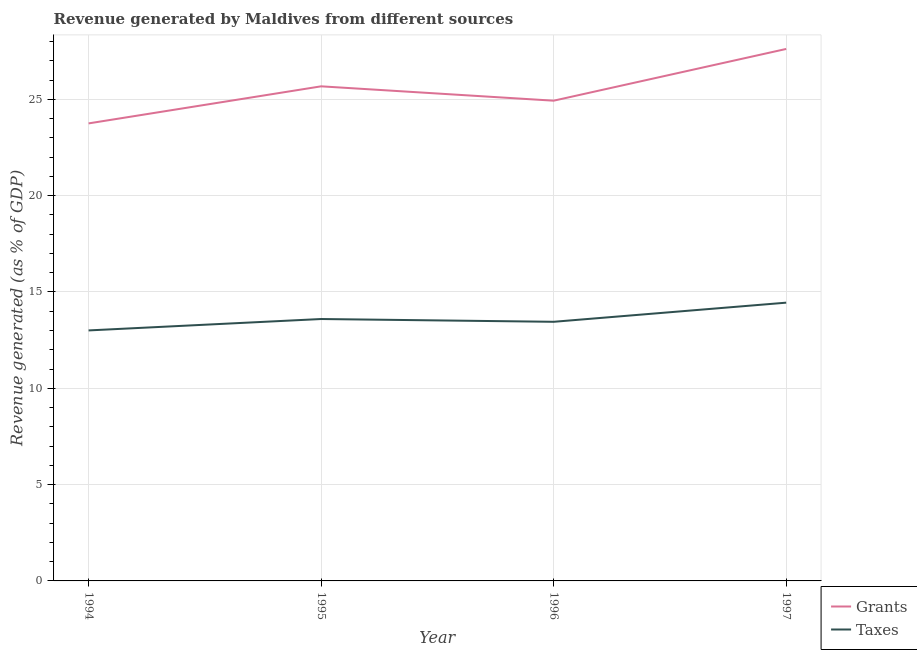How many different coloured lines are there?
Ensure brevity in your answer.  2. Does the line corresponding to revenue generated by taxes intersect with the line corresponding to revenue generated by grants?
Your answer should be very brief. No. What is the revenue generated by taxes in 1994?
Keep it short and to the point. 13. Across all years, what is the maximum revenue generated by taxes?
Give a very brief answer. 14.45. Across all years, what is the minimum revenue generated by grants?
Provide a succinct answer. 23.75. What is the total revenue generated by taxes in the graph?
Your answer should be very brief. 54.5. What is the difference between the revenue generated by grants in 1995 and that in 1997?
Make the answer very short. -1.94. What is the difference between the revenue generated by taxes in 1994 and the revenue generated by grants in 1995?
Ensure brevity in your answer.  -12.67. What is the average revenue generated by grants per year?
Provide a succinct answer. 25.49. In the year 1996, what is the difference between the revenue generated by taxes and revenue generated by grants?
Your answer should be compact. -11.48. What is the ratio of the revenue generated by taxes in 1994 to that in 1997?
Provide a short and direct response. 0.9. Is the difference between the revenue generated by taxes in 1994 and 1996 greater than the difference between the revenue generated by grants in 1994 and 1996?
Keep it short and to the point. Yes. What is the difference between the highest and the second highest revenue generated by taxes?
Provide a short and direct response. 0.85. What is the difference between the highest and the lowest revenue generated by taxes?
Give a very brief answer. 1.44. In how many years, is the revenue generated by taxes greater than the average revenue generated by taxes taken over all years?
Give a very brief answer. 1. Does the revenue generated by taxes monotonically increase over the years?
Give a very brief answer. No. Is the revenue generated by grants strictly less than the revenue generated by taxes over the years?
Make the answer very short. No. How many lines are there?
Your response must be concise. 2. How many years are there in the graph?
Your answer should be very brief. 4. What is the difference between two consecutive major ticks on the Y-axis?
Your response must be concise. 5. Where does the legend appear in the graph?
Keep it short and to the point. Bottom right. How many legend labels are there?
Give a very brief answer. 2. How are the legend labels stacked?
Provide a succinct answer. Vertical. What is the title of the graph?
Offer a very short reply. Revenue generated by Maldives from different sources. Does "RDB nonconcessional" appear as one of the legend labels in the graph?
Ensure brevity in your answer.  No. What is the label or title of the Y-axis?
Provide a short and direct response. Revenue generated (as % of GDP). What is the Revenue generated (as % of GDP) in Grants in 1994?
Keep it short and to the point. 23.75. What is the Revenue generated (as % of GDP) of Taxes in 1994?
Offer a very short reply. 13. What is the Revenue generated (as % of GDP) of Grants in 1995?
Ensure brevity in your answer.  25.68. What is the Revenue generated (as % of GDP) in Taxes in 1995?
Offer a very short reply. 13.6. What is the Revenue generated (as % of GDP) in Grants in 1996?
Your response must be concise. 24.93. What is the Revenue generated (as % of GDP) in Taxes in 1996?
Make the answer very short. 13.45. What is the Revenue generated (as % of GDP) in Grants in 1997?
Keep it short and to the point. 27.62. What is the Revenue generated (as % of GDP) of Taxes in 1997?
Provide a short and direct response. 14.45. Across all years, what is the maximum Revenue generated (as % of GDP) in Grants?
Your response must be concise. 27.62. Across all years, what is the maximum Revenue generated (as % of GDP) in Taxes?
Provide a succinct answer. 14.45. Across all years, what is the minimum Revenue generated (as % of GDP) in Grants?
Ensure brevity in your answer.  23.75. Across all years, what is the minimum Revenue generated (as % of GDP) in Taxes?
Provide a succinct answer. 13. What is the total Revenue generated (as % of GDP) of Grants in the graph?
Keep it short and to the point. 101.98. What is the total Revenue generated (as % of GDP) of Taxes in the graph?
Offer a terse response. 54.5. What is the difference between the Revenue generated (as % of GDP) of Grants in 1994 and that in 1995?
Ensure brevity in your answer.  -1.92. What is the difference between the Revenue generated (as % of GDP) of Taxes in 1994 and that in 1995?
Your answer should be compact. -0.59. What is the difference between the Revenue generated (as % of GDP) in Grants in 1994 and that in 1996?
Your answer should be very brief. -1.18. What is the difference between the Revenue generated (as % of GDP) of Taxes in 1994 and that in 1996?
Offer a terse response. -0.45. What is the difference between the Revenue generated (as % of GDP) of Grants in 1994 and that in 1997?
Keep it short and to the point. -3.87. What is the difference between the Revenue generated (as % of GDP) in Taxes in 1994 and that in 1997?
Keep it short and to the point. -1.44. What is the difference between the Revenue generated (as % of GDP) in Grants in 1995 and that in 1996?
Your answer should be compact. 0.75. What is the difference between the Revenue generated (as % of GDP) of Taxes in 1995 and that in 1996?
Provide a succinct answer. 0.14. What is the difference between the Revenue generated (as % of GDP) in Grants in 1995 and that in 1997?
Ensure brevity in your answer.  -1.94. What is the difference between the Revenue generated (as % of GDP) of Taxes in 1995 and that in 1997?
Provide a short and direct response. -0.85. What is the difference between the Revenue generated (as % of GDP) of Grants in 1996 and that in 1997?
Your answer should be very brief. -2.69. What is the difference between the Revenue generated (as % of GDP) in Taxes in 1996 and that in 1997?
Give a very brief answer. -0.99. What is the difference between the Revenue generated (as % of GDP) of Grants in 1994 and the Revenue generated (as % of GDP) of Taxes in 1995?
Give a very brief answer. 10.16. What is the difference between the Revenue generated (as % of GDP) of Grants in 1994 and the Revenue generated (as % of GDP) of Taxes in 1996?
Offer a very short reply. 10.3. What is the difference between the Revenue generated (as % of GDP) of Grants in 1994 and the Revenue generated (as % of GDP) of Taxes in 1997?
Offer a terse response. 9.31. What is the difference between the Revenue generated (as % of GDP) of Grants in 1995 and the Revenue generated (as % of GDP) of Taxes in 1996?
Your response must be concise. 12.22. What is the difference between the Revenue generated (as % of GDP) in Grants in 1995 and the Revenue generated (as % of GDP) in Taxes in 1997?
Offer a terse response. 11.23. What is the difference between the Revenue generated (as % of GDP) in Grants in 1996 and the Revenue generated (as % of GDP) in Taxes in 1997?
Your answer should be compact. 10.49. What is the average Revenue generated (as % of GDP) of Grants per year?
Your response must be concise. 25.49. What is the average Revenue generated (as % of GDP) in Taxes per year?
Your response must be concise. 13.62. In the year 1994, what is the difference between the Revenue generated (as % of GDP) of Grants and Revenue generated (as % of GDP) of Taxes?
Give a very brief answer. 10.75. In the year 1995, what is the difference between the Revenue generated (as % of GDP) of Grants and Revenue generated (as % of GDP) of Taxes?
Your response must be concise. 12.08. In the year 1996, what is the difference between the Revenue generated (as % of GDP) in Grants and Revenue generated (as % of GDP) in Taxes?
Ensure brevity in your answer.  11.48. In the year 1997, what is the difference between the Revenue generated (as % of GDP) in Grants and Revenue generated (as % of GDP) in Taxes?
Give a very brief answer. 13.17. What is the ratio of the Revenue generated (as % of GDP) in Grants in 1994 to that in 1995?
Your answer should be compact. 0.93. What is the ratio of the Revenue generated (as % of GDP) in Taxes in 1994 to that in 1995?
Offer a terse response. 0.96. What is the ratio of the Revenue generated (as % of GDP) of Grants in 1994 to that in 1996?
Give a very brief answer. 0.95. What is the ratio of the Revenue generated (as % of GDP) in Taxes in 1994 to that in 1996?
Your response must be concise. 0.97. What is the ratio of the Revenue generated (as % of GDP) of Grants in 1994 to that in 1997?
Your answer should be very brief. 0.86. What is the ratio of the Revenue generated (as % of GDP) of Taxes in 1994 to that in 1997?
Offer a terse response. 0.9. What is the ratio of the Revenue generated (as % of GDP) of Grants in 1995 to that in 1996?
Keep it short and to the point. 1.03. What is the ratio of the Revenue generated (as % of GDP) in Taxes in 1995 to that in 1996?
Your answer should be very brief. 1.01. What is the ratio of the Revenue generated (as % of GDP) of Grants in 1995 to that in 1997?
Ensure brevity in your answer.  0.93. What is the ratio of the Revenue generated (as % of GDP) of Grants in 1996 to that in 1997?
Your answer should be compact. 0.9. What is the ratio of the Revenue generated (as % of GDP) of Taxes in 1996 to that in 1997?
Give a very brief answer. 0.93. What is the difference between the highest and the second highest Revenue generated (as % of GDP) in Grants?
Keep it short and to the point. 1.94. What is the difference between the highest and the second highest Revenue generated (as % of GDP) in Taxes?
Your answer should be very brief. 0.85. What is the difference between the highest and the lowest Revenue generated (as % of GDP) of Grants?
Provide a short and direct response. 3.87. What is the difference between the highest and the lowest Revenue generated (as % of GDP) of Taxes?
Offer a terse response. 1.44. 